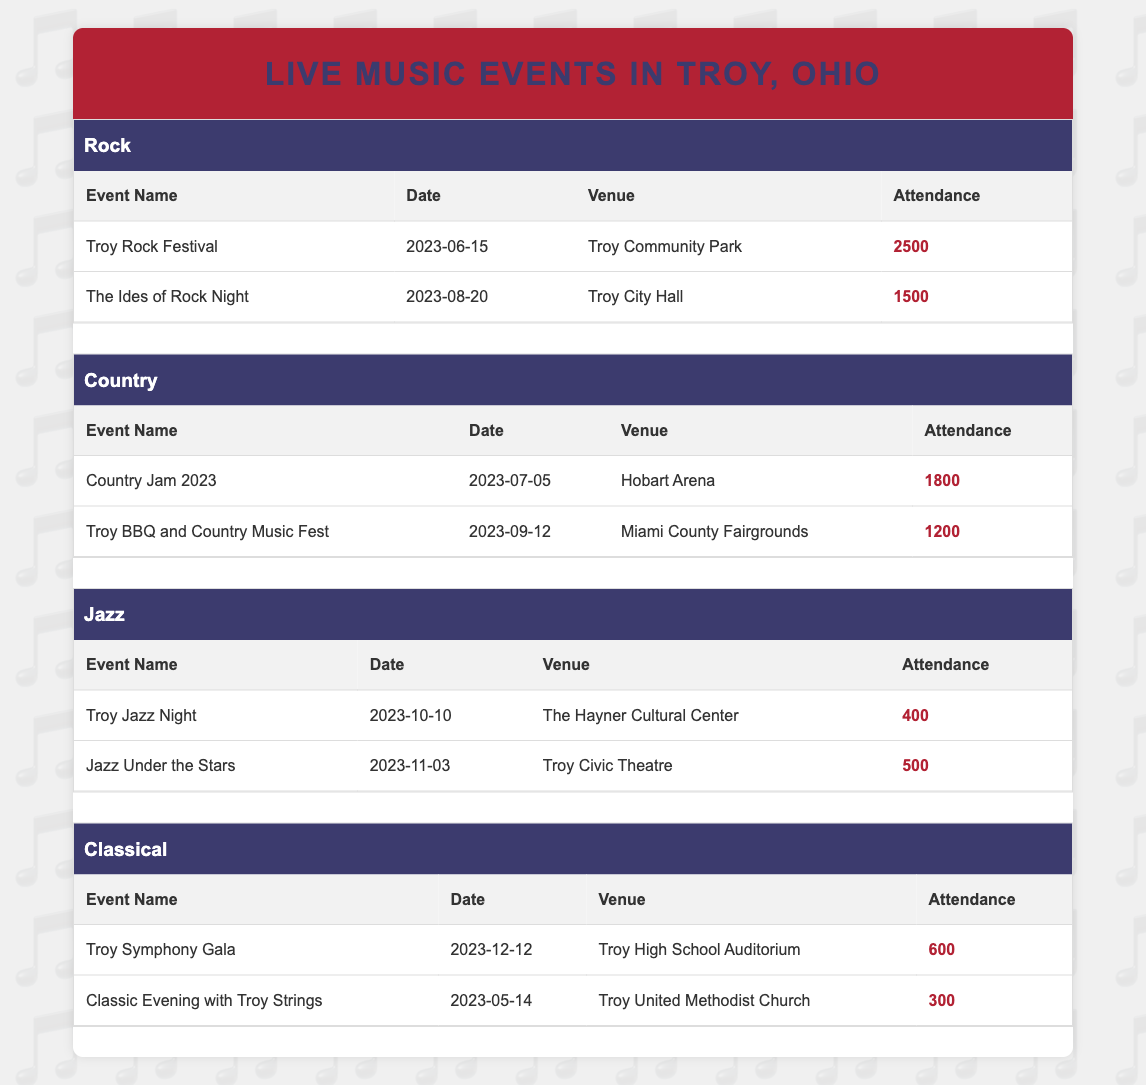What is the highest attendance recorded for a live music event in Troy? The highest attendance can be found by examining all the attendance numbers in the table. The numbers listed are 2500, 1500, 1800, 1200, 400, 500, 600, and 300. The maximum value among these is 2500, which corresponds to the "Troy Rock Festival."
Answer: 2500 Which event had the lowest attendance? Looking through the attendance figures of all events, we find that the lowest number is 300, related to the "Classic Evening with Troy Strings."
Answer: 300 How many events had an attendance of over 1000? By checking each attendance figure, the events over 1000 attendees are: "Troy Rock Festival" (2500), "The Ides of Rock Night" (1500), "Country Jam 2023" (1800), and "Troy BBQ and Country Music Fest" (1200). That gives us a total of 4 events.
Answer: 4 What is the average attendance across all genres? To find the average, first sum all the attendance numbers: 2500 + 1500 + 1800 + 1200 + 400 + 500 + 600 + 300 = 8300. Since there are 8 events, the average is calculated as 8300 / 8 = 1037.5.
Answer: 1037.5 True or False: The "Jazz Under the Stars" had more attendees than the "Troy BBQ and Country Music Fest." Comparing the attendance figures, "Jazz Under the Stars" had 500 attendees while "Troy BBQ and Country Music Fest" had 1200. Since 500 is less than 1200, the statement is False.
Answer: False Which venue hosted the event with the most attendees? The venue for the highest attendance, which is 2500 at the "Troy Rock Festival," is the "Troy Community Park." Thus, this venue hosted the most attended event.
Answer: Troy Community Park How many events were held in October or later? The events scheduled in October or later include "Troy Jazz Night" (October 10) and "Jazz Under the Stars" (November 3), and "Troy Symphony Gala" (December 12). Thus, there are 3 events.
Answer: 3 Is there any event in the Classical genre with more than 600 attendees? The attendance for the Classical genre events are "Troy Symphony Gala" (600) and "Classic Evening with Troy Strings" (300). Neither exceeds 600, making the statement false.
Answer: False 